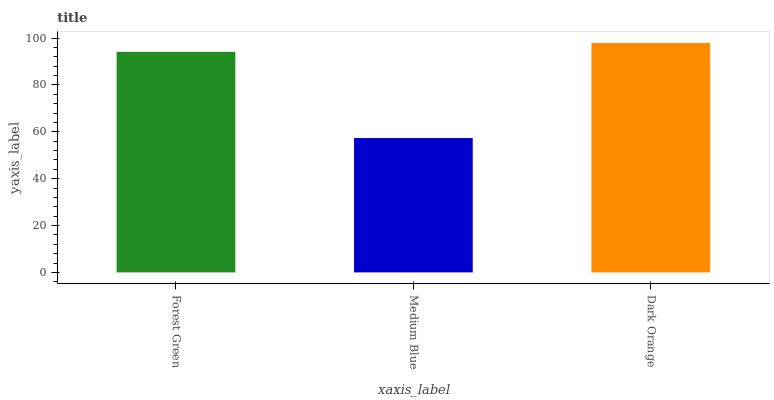Is Dark Orange the minimum?
Answer yes or no. No. Is Medium Blue the maximum?
Answer yes or no. No. Is Dark Orange greater than Medium Blue?
Answer yes or no. Yes. Is Medium Blue less than Dark Orange?
Answer yes or no. Yes. Is Medium Blue greater than Dark Orange?
Answer yes or no. No. Is Dark Orange less than Medium Blue?
Answer yes or no. No. Is Forest Green the high median?
Answer yes or no. Yes. Is Forest Green the low median?
Answer yes or no. Yes. Is Medium Blue the high median?
Answer yes or no. No. Is Dark Orange the low median?
Answer yes or no. No. 